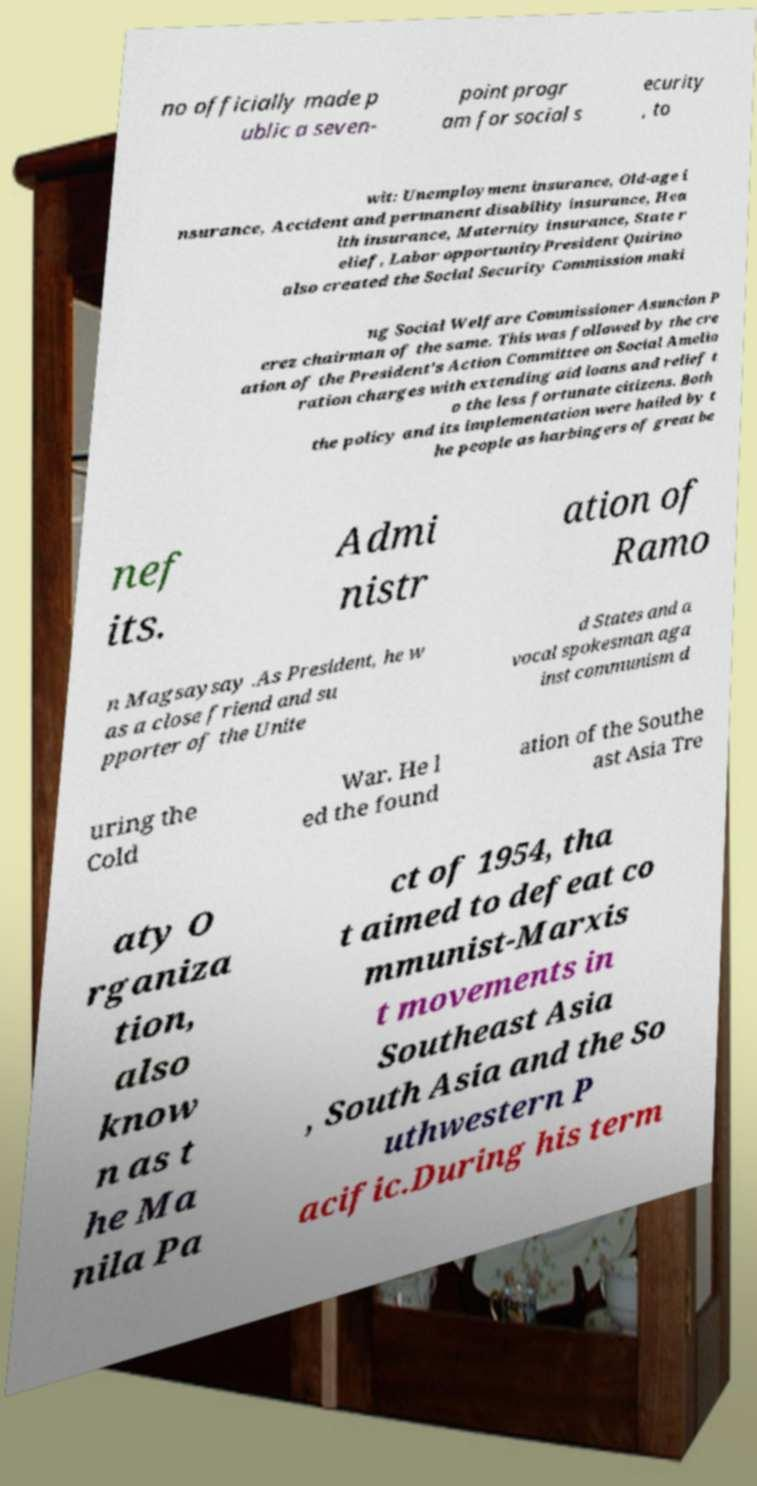Please identify and transcribe the text found in this image. no officially made p ublic a seven- point progr am for social s ecurity , to wit: Unemployment insurance, Old-age i nsurance, Accident and permanent disability insurance, Hea lth insurance, Maternity insurance, State r elief, Labor opportunityPresident Quirino also created the Social Security Commission maki ng Social Welfare Commissioner Asuncion P erez chairman of the same. This was followed by the cre ation of the President's Action Committee on Social Amelio ration charges with extending aid loans and relief t o the less fortunate citizens. Both the policy and its implementation were hailed by t he people as harbingers of great be nef its. Admi nistr ation of Ramo n Magsaysay .As President, he w as a close friend and su pporter of the Unite d States and a vocal spokesman aga inst communism d uring the Cold War. He l ed the found ation of the Southe ast Asia Tre aty O rganiza tion, also know n as t he Ma nila Pa ct of 1954, tha t aimed to defeat co mmunist-Marxis t movements in Southeast Asia , South Asia and the So uthwestern P acific.During his term 